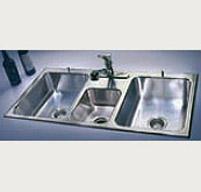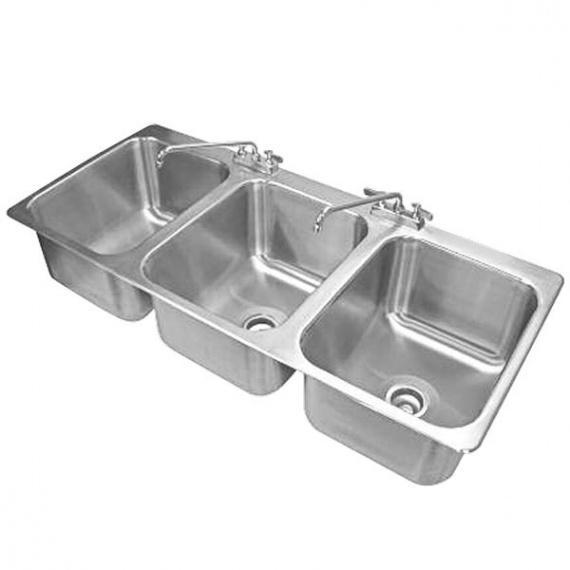The first image is the image on the left, the second image is the image on the right. Analyze the images presented: Is the assertion "Two silvery metal prep sinks stand on legs, and each has two or more sink bowls." valid? Answer yes or no. No. 